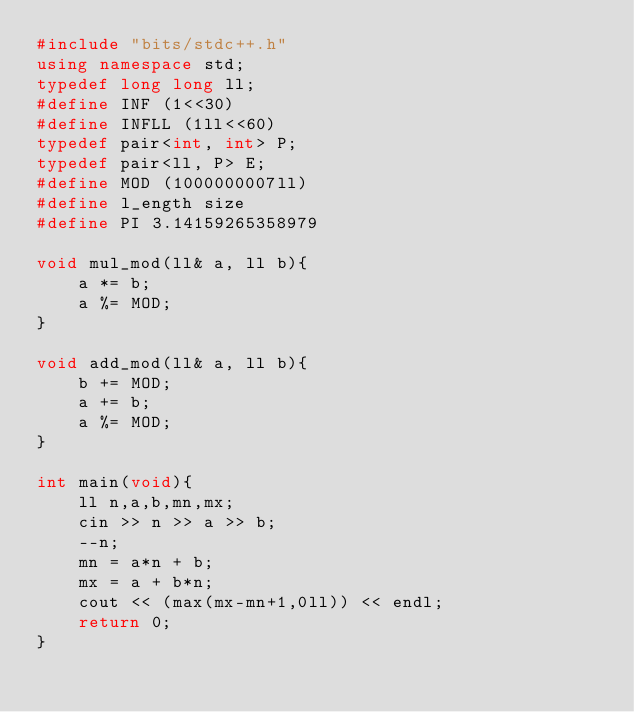<code> <loc_0><loc_0><loc_500><loc_500><_C++_>#include "bits/stdc++.h"
using namespace std;
typedef long long ll;
#define INF (1<<30)
#define INFLL (1ll<<60)
typedef pair<int, int> P;
typedef pair<ll, P> E;
#define MOD (1000000007ll)
#define l_ength size
#define PI 3.14159265358979

void mul_mod(ll& a, ll b){
	a *= b;
	a %= MOD;
}

void add_mod(ll& a, ll b){
	b += MOD;
	a += b;
	a %= MOD;
}

int main(void){
	ll n,a,b,mn,mx;
	cin >> n >> a >> b;
	--n;
	mn = a*n + b;
	mx = a + b*n;
	cout << (max(mx-mn+1,0ll)) << endl;
	return 0;
}

</code> 